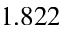<formula> <loc_0><loc_0><loc_500><loc_500>1 . 8 2 2</formula> 